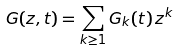Convert formula to latex. <formula><loc_0><loc_0><loc_500><loc_500>G ( z , t ) = \sum _ { k \geq 1 } G _ { k } ( t ) \, z ^ { k }</formula> 